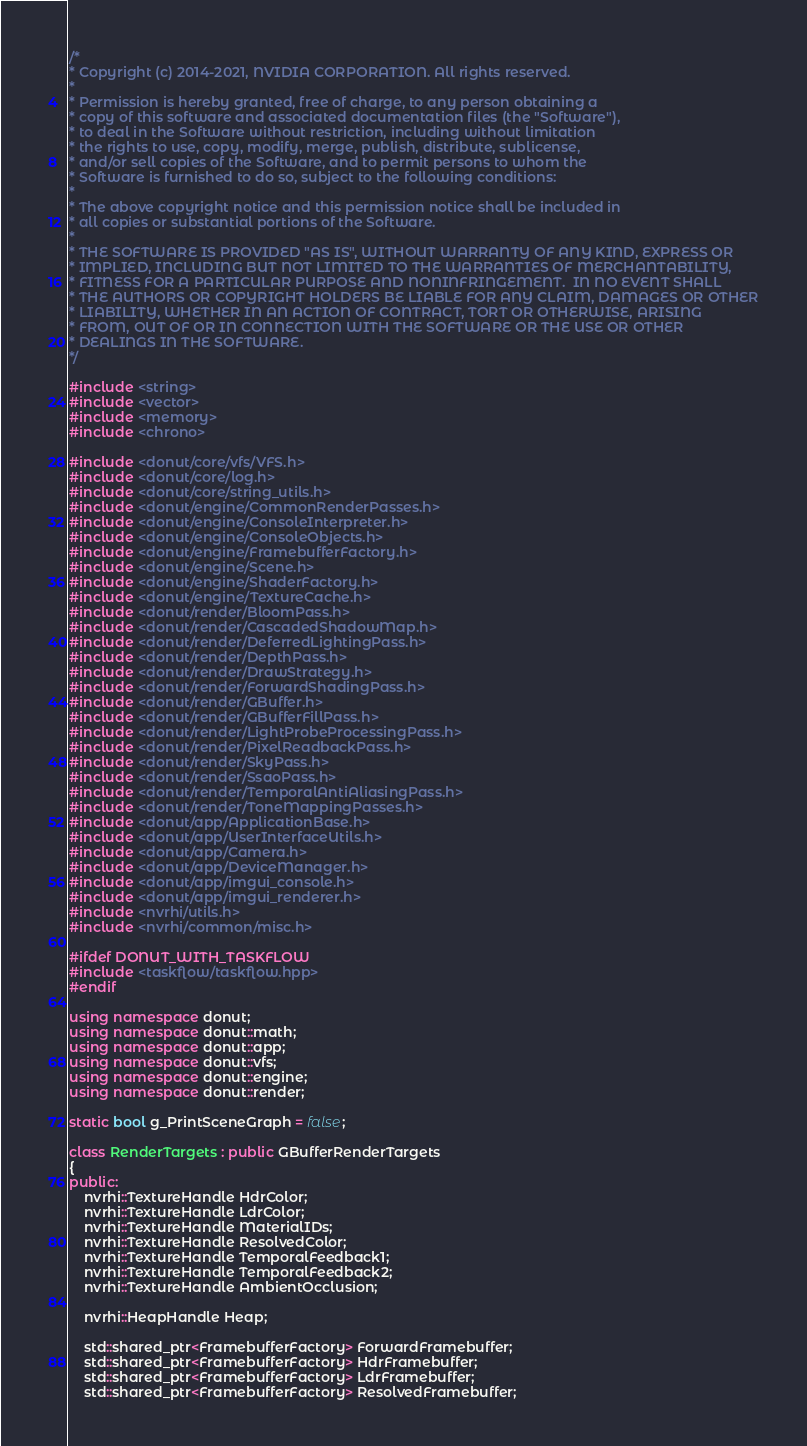Convert code to text. <code><loc_0><loc_0><loc_500><loc_500><_C++_>/*
* Copyright (c) 2014-2021, NVIDIA CORPORATION. All rights reserved.
*
* Permission is hereby granted, free of charge, to any person obtaining a
* copy of this software and associated documentation files (the "Software"),
* to deal in the Software without restriction, including without limitation
* the rights to use, copy, modify, merge, publish, distribute, sublicense,
* and/or sell copies of the Software, and to permit persons to whom the
* Software is furnished to do so, subject to the following conditions:
*
* The above copyright notice and this permission notice shall be included in
* all copies or substantial portions of the Software.
*
* THE SOFTWARE IS PROVIDED "AS IS", WITHOUT WARRANTY OF ANY KIND, EXPRESS OR
* IMPLIED, INCLUDING BUT NOT LIMITED TO THE WARRANTIES OF MERCHANTABILITY,
* FITNESS FOR A PARTICULAR PURPOSE AND NONINFRINGEMENT.  IN NO EVENT SHALL
* THE AUTHORS OR COPYRIGHT HOLDERS BE LIABLE FOR ANY CLAIM, DAMAGES OR OTHER
* LIABILITY, WHETHER IN AN ACTION OF CONTRACT, TORT OR OTHERWISE, ARISING
* FROM, OUT OF OR IN CONNECTION WITH THE SOFTWARE OR THE USE OR OTHER
* DEALINGS IN THE SOFTWARE.
*/

#include <string>
#include <vector>
#include <memory>
#include <chrono>

#include <donut/core/vfs/VFS.h>
#include <donut/core/log.h>
#include <donut/core/string_utils.h>
#include <donut/engine/CommonRenderPasses.h>
#include <donut/engine/ConsoleInterpreter.h>
#include <donut/engine/ConsoleObjects.h>
#include <donut/engine/FramebufferFactory.h>
#include <donut/engine/Scene.h>
#include <donut/engine/ShaderFactory.h>
#include <donut/engine/TextureCache.h>
#include <donut/render/BloomPass.h>
#include <donut/render/CascadedShadowMap.h>
#include <donut/render/DeferredLightingPass.h>
#include <donut/render/DepthPass.h>
#include <donut/render/DrawStrategy.h>
#include <donut/render/ForwardShadingPass.h>
#include <donut/render/GBuffer.h>
#include <donut/render/GBufferFillPass.h>
#include <donut/render/LightProbeProcessingPass.h>
#include <donut/render/PixelReadbackPass.h>
#include <donut/render/SkyPass.h>
#include <donut/render/SsaoPass.h>
#include <donut/render/TemporalAntiAliasingPass.h>
#include <donut/render/ToneMappingPasses.h>
#include <donut/app/ApplicationBase.h>
#include <donut/app/UserInterfaceUtils.h>
#include <donut/app/Camera.h>
#include <donut/app/DeviceManager.h>
#include <donut/app/imgui_console.h>
#include <donut/app/imgui_renderer.h>
#include <nvrhi/utils.h>
#include <nvrhi/common/misc.h>

#ifdef DONUT_WITH_TASKFLOW
#include <taskflow/taskflow.hpp>
#endif

using namespace donut;
using namespace donut::math;
using namespace donut::app;
using namespace donut::vfs;
using namespace donut::engine;
using namespace donut::render;

static bool g_PrintSceneGraph = false;

class RenderTargets : public GBufferRenderTargets
{
public:
    nvrhi::TextureHandle HdrColor;
    nvrhi::TextureHandle LdrColor;
    nvrhi::TextureHandle MaterialIDs;
    nvrhi::TextureHandle ResolvedColor;
    nvrhi::TextureHandle TemporalFeedback1;
    nvrhi::TextureHandle TemporalFeedback2;
    nvrhi::TextureHandle AmbientOcclusion;

    nvrhi::HeapHandle Heap;

    std::shared_ptr<FramebufferFactory> ForwardFramebuffer;
    std::shared_ptr<FramebufferFactory> HdrFramebuffer;
    std::shared_ptr<FramebufferFactory> LdrFramebuffer;
    std::shared_ptr<FramebufferFactory> ResolvedFramebuffer;</code> 